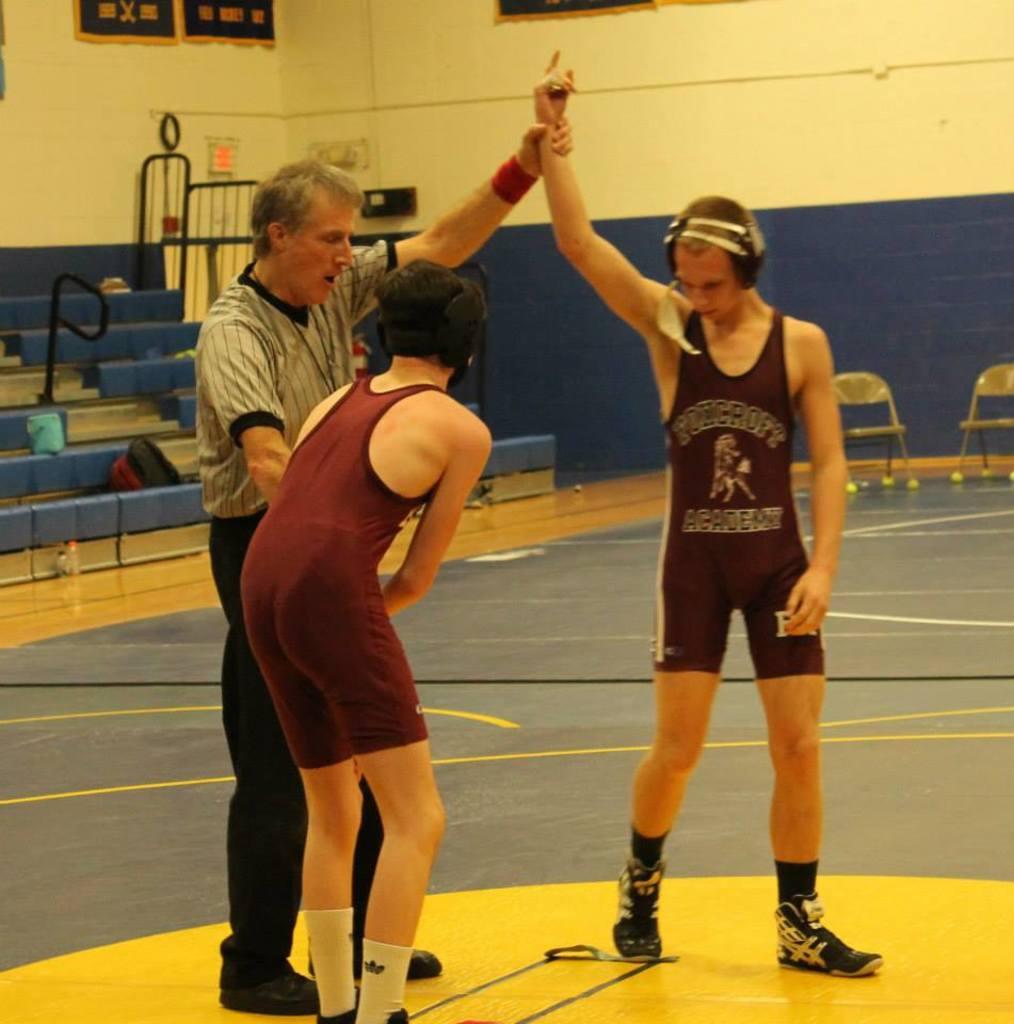What school does the wrestler with his arm up attend?
Your response must be concise. Foxcroft academy. 